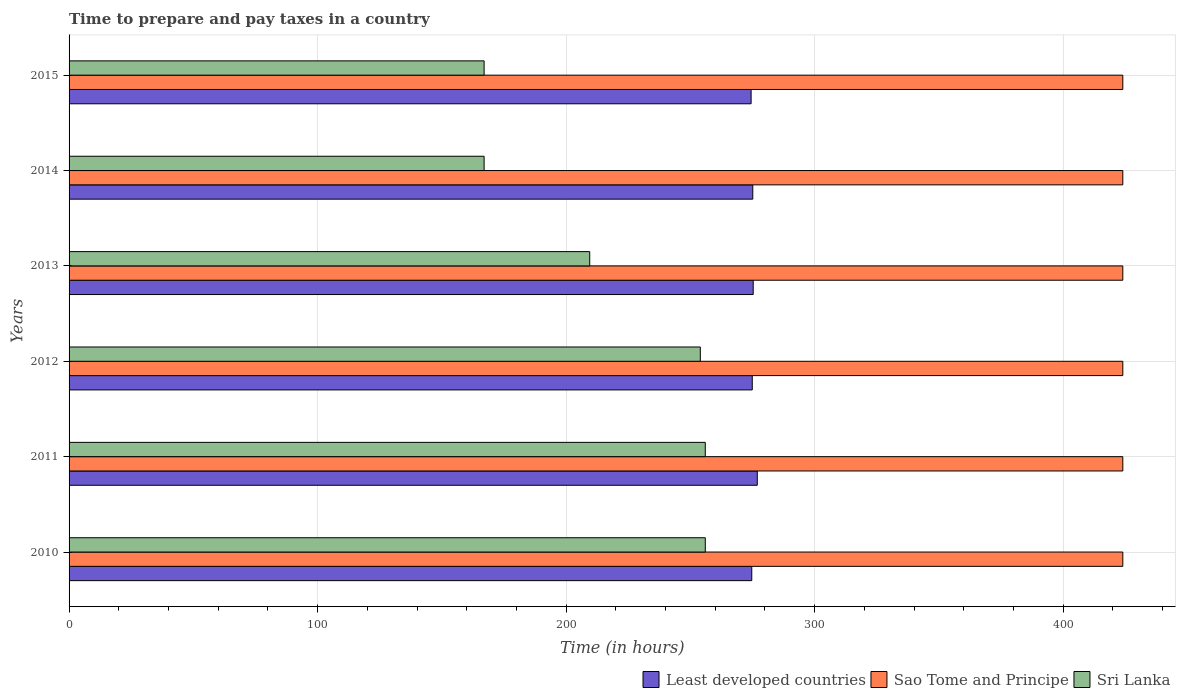How many different coloured bars are there?
Give a very brief answer. 3. Are the number of bars per tick equal to the number of legend labels?
Give a very brief answer. Yes. Are the number of bars on each tick of the Y-axis equal?
Your response must be concise. Yes. What is the number of hours required to prepare and pay taxes in Least developed countries in 2014?
Ensure brevity in your answer.  275.11. Across all years, what is the maximum number of hours required to prepare and pay taxes in Sri Lanka?
Your response must be concise. 256. Across all years, what is the minimum number of hours required to prepare and pay taxes in Sao Tome and Principe?
Offer a very short reply. 424. What is the total number of hours required to prepare and pay taxes in Sao Tome and Principe in the graph?
Your answer should be compact. 2544. What is the difference between the number of hours required to prepare and pay taxes in Least developed countries in 2012 and that in 2015?
Ensure brevity in your answer.  0.47. What is the difference between the number of hours required to prepare and pay taxes in Sri Lanka in 2014 and the number of hours required to prepare and pay taxes in Sao Tome and Principe in 2013?
Your response must be concise. -257. What is the average number of hours required to prepare and pay taxes in Sri Lanka per year?
Keep it short and to the point. 218.25. In the year 2012, what is the difference between the number of hours required to prepare and pay taxes in Sri Lanka and number of hours required to prepare and pay taxes in Least developed countries?
Give a very brief answer. -20.9. In how many years, is the number of hours required to prepare and pay taxes in Least developed countries greater than 220 hours?
Your response must be concise. 6. What is the ratio of the number of hours required to prepare and pay taxes in Least developed countries in 2011 to that in 2013?
Offer a terse response. 1.01. Is the number of hours required to prepare and pay taxes in Sao Tome and Principe in 2010 less than that in 2015?
Keep it short and to the point. No. What is the difference between the highest and the lowest number of hours required to prepare and pay taxes in Sri Lanka?
Provide a short and direct response. 89. What does the 3rd bar from the top in 2011 represents?
Keep it short and to the point. Least developed countries. What does the 2nd bar from the bottom in 2013 represents?
Offer a terse response. Sao Tome and Principe. Is it the case that in every year, the sum of the number of hours required to prepare and pay taxes in Sao Tome and Principe and number of hours required to prepare and pay taxes in Sri Lanka is greater than the number of hours required to prepare and pay taxes in Least developed countries?
Your response must be concise. Yes. How many bars are there?
Provide a succinct answer. 18. How many years are there in the graph?
Provide a short and direct response. 6. What is the difference between two consecutive major ticks on the X-axis?
Your response must be concise. 100. Where does the legend appear in the graph?
Your response must be concise. Bottom right. How many legend labels are there?
Provide a short and direct response. 3. How are the legend labels stacked?
Provide a succinct answer. Horizontal. What is the title of the graph?
Make the answer very short. Time to prepare and pay taxes in a country. Does "Brunei Darussalam" appear as one of the legend labels in the graph?
Offer a terse response. No. What is the label or title of the X-axis?
Your response must be concise. Time (in hours). What is the label or title of the Y-axis?
Offer a very short reply. Years. What is the Time (in hours) of Least developed countries in 2010?
Provide a succinct answer. 274.7. What is the Time (in hours) of Sao Tome and Principe in 2010?
Ensure brevity in your answer.  424. What is the Time (in hours) of Sri Lanka in 2010?
Provide a succinct answer. 256. What is the Time (in hours) in Least developed countries in 2011?
Offer a very short reply. 276.92. What is the Time (in hours) in Sao Tome and Principe in 2011?
Ensure brevity in your answer.  424. What is the Time (in hours) in Sri Lanka in 2011?
Your answer should be very brief. 256. What is the Time (in hours) of Least developed countries in 2012?
Give a very brief answer. 274.9. What is the Time (in hours) in Sao Tome and Principe in 2012?
Your answer should be very brief. 424. What is the Time (in hours) in Sri Lanka in 2012?
Provide a succinct answer. 254. What is the Time (in hours) in Least developed countries in 2013?
Your response must be concise. 275.28. What is the Time (in hours) of Sao Tome and Principe in 2013?
Provide a succinct answer. 424. What is the Time (in hours) of Sri Lanka in 2013?
Ensure brevity in your answer.  209.5. What is the Time (in hours) in Least developed countries in 2014?
Give a very brief answer. 275.11. What is the Time (in hours) of Sao Tome and Principe in 2014?
Make the answer very short. 424. What is the Time (in hours) of Sri Lanka in 2014?
Make the answer very short. 167. What is the Time (in hours) of Least developed countries in 2015?
Your answer should be very brief. 274.43. What is the Time (in hours) in Sao Tome and Principe in 2015?
Make the answer very short. 424. What is the Time (in hours) in Sri Lanka in 2015?
Keep it short and to the point. 167. Across all years, what is the maximum Time (in hours) in Least developed countries?
Your response must be concise. 276.92. Across all years, what is the maximum Time (in hours) in Sao Tome and Principe?
Give a very brief answer. 424. Across all years, what is the maximum Time (in hours) in Sri Lanka?
Provide a short and direct response. 256. Across all years, what is the minimum Time (in hours) of Least developed countries?
Keep it short and to the point. 274.43. Across all years, what is the minimum Time (in hours) in Sao Tome and Principe?
Keep it short and to the point. 424. Across all years, what is the minimum Time (in hours) in Sri Lanka?
Your answer should be very brief. 167. What is the total Time (in hours) in Least developed countries in the graph?
Provide a short and direct response. 1651.35. What is the total Time (in hours) of Sao Tome and Principe in the graph?
Give a very brief answer. 2544. What is the total Time (in hours) in Sri Lanka in the graph?
Keep it short and to the point. 1309.5. What is the difference between the Time (in hours) of Least developed countries in 2010 and that in 2011?
Offer a terse response. -2.21. What is the difference between the Time (in hours) in Least developed countries in 2010 and that in 2012?
Ensure brevity in your answer.  -0.2. What is the difference between the Time (in hours) of Least developed countries in 2010 and that in 2013?
Your answer should be compact. -0.58. What is the difference between the Time (in hours) in Sao Tome and Principe in 2010 and that in 2013?
Provide a short and direct response. 0. What is the difference between the Time (in hours) of Sri Lanka in 2010 and that in 2013?
Ensure brevity in your answer.  46.5. What is the difference between the Time (in hours) of Least developed countries in 2010 and that in 2014?
Make the answer very short. -0.4. What is the difference between the Time (in hours) in Sao Tome and Principe in 2010 and that in 2014?
Provide a short and direct response. 0. What is the difference between the Time (in hours) of Sri Lanka in 2010 and that in 2014?
Your response must be concise. 89. What is the difference between the Time (in hours) in Least developed countries in 2010 and that in 2015?
Offer a very short reply. 0.27. What is the difference between the Time (in hours) of Sao Tome and Principe in 2010 and that in 2015?
Your response must be concise. 0. What is the difference between the Time (in hours) of Sri Lanka in 2010 and that in 2015?
Offer a terse response. 89. What is the difference between the Time (in hours) in Least developed countries in 2011 and that in 2012?
Your answer should be very brief. 2.02. What is the difference between the Time (in hours) of Sao Tome and Principe in 2011 and that in 2012?
Provide a succinct answer. 0. What is the difference between the Time (in hours) in Least developed countries in 2011 and that in 2013?
Give a very brief answer. 1.64. What is the difference between the Time (in hours) of Sao Tome and Principe in 2011 and that in 2013?
Provide a short and direct response. 0. What is the difference between the Time (in hours) in Sri Lanka in 2011 and that in 2013?
Offer a very short reply. 46.5. What is the difference between the Time (in hours) in Least developed countries in 2011 and that in 2014?
Provide a short and direct response. 1.81. What is the difference between the Time (in hours) in Sri Lanka in 2011 and that in 2014?
Offer a very short reply. 89. What is the difference between the Time (in hours) in Least developed countries in 2011 and that in 2015?
Keep it short and to the point. 2.48. What is the difference between the Time (in hours) of Sri Lanka in 2011 and that in 2015?
Give a very brief answer. 89. What is the difference between the Time (in hours) of Least developed countries in 2012 and that in 2013?
Keep it short and to the point. -0.38. What is the difference between the Time (in hours) in Sri Lanka in 2012 and that in 2013?
Provide a succinct answer. 44.5. What is the difference between the Time (in hours) of Least developed countries in 2012 and that in 2014?
Your response must be concise. -0.21. What is the difference between the Time (in hours) in Sao Tome and Principe in 2012 and that in 2014?
Make the answer very short. 0. What is the difference between the Time (in hours) in Sri Lanka in 2012 and that in 2014?
Offer a terse response. 87. What is the difference between the Time (in hours) of Least developed countries in 2012 and that in 2015?
Your answer should be very brief. 0.47. What is the difference between the Time (in hours) in Sri Lanka in 2012 and that in 2015?
Your response must be concise. 87. What is the difference between the Time (in hours) in Least developed countries in 2013 and that in 2014?
Ensure brevity in your answer.  0.17. What is the difference between the Time (in hours) of Sao Tome and Principe in 2013 and that in 2014?
Make the answer very short. 0. What is the difference between the Time (in hours) in Sri Lanka in 2013 and that in 2014?
Your response must be concise. 42.5. What is the difference between the Time (in hours) of Least developed countries in 2013 and that in 2015?
Provide a succinct answer. 0.85. What is the difference between the Time (in hours) of Sao Tome and Principe in 2013 and that in 2015?
Offer a terse response. 0. What is the difference between the Time (in hours) of Sri Lanka in 2013 and that in 2015?
Your response must be concise. 42.5. What is the difference between the Time (in hours) of Least developed countries in 2014 and that in 2015?
Offer a very short reply. 0.67. What is the difference between the Time (in hours) in Least developed countries in 2010 and the Time (in hours) in Sao Tome and Principe in 2011?
Your answer should be very brief. -149.3. What is the difference between the Time (in hours) of Least developed countries in 2010 and the Time (in hours) of Sri Lanka in 2011?
Your answer should be very brief. 18.7. What is the difference between the Time (in hours) of Sao Tome and Principe in 2010 and the Time (in hours) of Sri Lanka in 2011?
Your answer should be compact. 168. What is the difference between the Time (in hours) in Least developed countries in 2010 and the Time (in hours) in Sao Tome and Principe in 2012?
Make the answer very short. -149.3. What is the difference between the Time (in hours) of Least developed countries in 2010 and the Time (in hours) of Sri Lanka in 2012?
Your response must be concise. 20.7. What is the difference between the Time (in hours) of Sao Tome and Principe in 2010 and the Time (in hours) of Sri Lanka in 2012?
Keep it short and to the point. 170. What is the difference between the Time (in hours) of Least developed countries in 2010 and the Time (in hours) of Sao Tome and Principe in 2013?
Give a very brief answer. -149.3. What is the difference between the Time (in hours) of Least developed countries in 2010 and the Time (in hours) of Sri Lanka in 2013?
Offer a terse response. 65.2. What is the difference between the Time (in hours) of Sao Tome and Principe in 2010 and the Time (in hours) of Sri Lanka in 2013?
Make the answer very short. 214.5. What is the difference between the Time (in hours) in Least developed countries in 2010 and the Time (in hours) in Sao Tome and Principe in 2014?
Offer a terse response. -149.3. What is the difference between the Time (in hours) of Least developed countries in 2010 and the Time (in hours) of Sri Lanka in 2014?
Give a very brief answer. 107.7. What is the difference between the Time (in hours) in Sao Tome and Principe in 2010 and the Time (in hours) in Sri Lanka in 2014?
Ensure brevity in your answer.  257. What is the difference between the Time (in hours) in Least developed countries in 2010 and the Time (in hours) in Sao Tome and Principe in 2015?
Your answer should be very brief. -149.3. What is the difference between the Time (in hours) of Least developed countries in 2010 and the Time (in hours) of Sri Lanka in 2015?
Give a very brief answer. 107.7. What is the difference between the Time (in hours) of Sao Tome and Principe in 2010 and the Time (in hours) of Sri Lanka in 2015?
Give a very brief answer. 257. What is the difference between the Time (in hours) of Least developed countries in 2011 and the Time (in hours) of Sao Tome and Principe in 2012?
Ensure brevity in your answer.  -147.08. What is the difference between the Time (in hours) of Least developed countries in 2011 and the Time (in hours) of Sri Lanka in 2012?
Offer a terse response. 22.92. What is the difference between the Time (in hours) of Sao Tome and Principe in 2011 and the Time (in hours) of Sri Lanka in 2012?
Provide a succinct answer. 170. What is the difference between the Time (in hours) in Least developed countries in 2011 and the Time (in hours) in Sao Tome and Principe in 2013?
Offer a terse response. -147.08. What is the difference between the Time (in hours) in Least developed countries in 2011 and the Time (in hours) in Sri Lanka in 2013?
Offer a very short reply. 67.42. What is the difference between the Time (in hours) of Sao Tome and Principe in 2011 and the Time (in hours) of Sri Lanka in 2013?
Offer a very short reply. 214.5. What is the difference between the Time (in hours) of Least developed countries in 2011 and the Time (in hours) of Sao Tome and Principe in 2014?
Keep it short and to the point. -147.08. What is the difference between the Time (in hours) of Least developed countries in 2011 and the Time (in hours) of Sri Lanka in 2014?
Your answer should be compact. 109.92. What is the difference between the Time (in hours) in Sao Tome and Principe in 2011 and the Time (in hours) in Sri Lanka in 2014?
Make the answer very short. 257. What is the difference between the Time (in hours) in Least developed countries in 2011 and the Time (in hours) in Sao Tome and Principe in 2015?
Your response must be concise. -147.08. What is the difference between the Time (in hours) of Least developed countries in 2011 and the Time (in hours) of Sri Lanka in 2015?
Your answer should be very brief. 109.92. What is the difference between the Time (in hours) of Sao Tome and Principe in 2011 and the Time (in hours) of Sri Lanka in 2015?
Ensure brevity in your answer.  257. What is the difference between the Time (in hours) of Least developed countries in 2012 and the Time (in hours) of Sao Tome and Principe in 2013?
Offer a terse response. -149.1. What is the difference between the Time (in hours) in Least developed countries in 2012 and the Time (in hours) in Sri Lanka in 2013?
Keep it short and to the point. 65.4. What is the difference between the Time (in hours) in Sao Tome and Principe in 2012 and the Time (in hours) in Sri Lanka in 2013?
Your answer should be very brief. 214.5. What is the difference between the Time (in hours) in Least developed countries in 2012 and the Time (in hours) in Sao Tome and Principe in 2014?
Offer a very short reply. -149.1. What is the difference between the Time (in hours) in Least developed countries in 2012 and the Time (in hours) in Sri Lanka in 2014?
Ensure brevity in your answer.  107.9. What is the difference between the Time (in hours) in Sao Tome and Principe in 2012 and the Time (in hours) in Sri Lanka in 2014?
Your answer should be compact. 257. What is the difference between the Time (in hours) in Least developed countries in 2012 and the Time (in hours) in Sao Tome and Principe in 2015?
Give a very brief answer. -149.1. What is the difference between the Time (in hours) of Least developed countries in 2012 and the Time (in hours) of Sri Lanka in 2015?
Ensure brevity in your answer.  107.9. What is the difference between the Time (in hours) in Sao Tome and Principe in 2012 and the Time (in hours) in Sri Lanka in 2015?
Provide a succinct answer. 257. What is the difference between the Time (in hours) in Least developed countries in 2013 and the Time (in hours) in Sao Tome and Principe in 2014?
Make the answer very short. -148.72. What is the difference between the Time (in hours) of Least developed countries in 2013 and the Time (in hours) of Sri Lanka in 2014?
Give a very brief answer. 108.28. What is the difference between the Time (in hours) of Sao Tome and Principe in 2013 and the Time (in hours) of Sri Lanka in 2014?
Provide a succinct answer. 257. What is the difference between the Time (in hours) in Least developed countries in 2013 and the Time (in hours) in Sao Tome and Principe in 2015?
Provide a succinct answer. -148.72. What is the difference between the Time (in hours) of Least developed countries in 2013 and the Time (in hours) of Sri Lanka in 2015?
Keep it short and to the point. 108.28. What is the difference between the Time (in hours) in Sao Tome and Principe in 2013 and the Time (in hours) in Sri Lanka in 2015?
Provide a succinct answer. 257. What is the difference between the Time (in hours) in Least developed countries in 2014 and the Time (in hours) in Sao Tome and Principe in 2015?
Give a very brief answer. -148.89. What is the difference between the Time (in hours) of Least developed countries in 2014 and the Time (in hours) of Sri Lanka in 2015?
Keep it short and to the point. 108.11. What is the difference between the Time (in hours) in Sao Tome and Principe in 2014 and the Time (in hours) in Sri Lanka in 2015?
Give a very brief answer. 257. What is the average Time (in hours) of Least developed countries per year?
Offer a very short reply. 275.22. What is the average Time (in hours) of Sao Tome and Principe per year?
Offer a very short reply. 424. What is the average Time (in hours) of Sri Lanka per year?
Provide a succinct answer. 218.25. In the year 2010, what is the difference between the Time (in hours) of Least developed countries and Time (in hours) of Sao Tome and Principe?
Provide a short and direct response. -149.3. In the year 2010, what is the difference between the Time (in hours) in Least developed countries and Time (in hours) in Sri Lanka?
Give a very brief answer. 18.7. In the year 2010, what is the difference between the Time (in hours) of Sao Tome and Principe and Time (in hours) of Sri Lanka?
Give a very brief answer. 168. In the year 2011, what is the difference between the Time (in hours) of Least developed countries and Time (in hours) of Sao Tome and Principe?
Offer a very short reply. -147.08. In the year 2011, what is the difference between the Time (in hours) of Least developed countries and Time (in hours) of Sri Lanka?
Give a very brief answer. 20.92. In the year 2011, what is the difference between the Time (in hours) of Sao Tome and Principe and Time (in hours) of Sri Lanka?
Provide a short and direct response. 168. In the year 2012, what is the difference between the Time (in hours) of Least developed countries and Time (in hours) of Sao Tome and Principe?
Your response must be concise. -149.1. In the year 2012, what is the difference between the Time (in hours) in Least developed countries and Time (in hours) in Sri Lanka?
Your response must be concise. 20.9. In the year 2012, what is the difference between the Time (in hours) in Sao Tome and Principe and Time (in hours) in Sri Lanka?
Keep it short and to the point. 170. In the year 2013, what is the difference between the Time (in hours) in Least developed countries and Time (in hours) in Sao Tome and Principe?
Your answer should be compact. -148.72. In the year 2013, what is the difference between the Time (in hours) of Least developed countries and Time (in hours) of Sri Lanka?
Ensure brevity in your answer.  65.78. In the year 2013, what is the difference between the Time (in hours) in Sao Tome and Principe and Time (in hours) in Sri Lanka?
Your answer should be compact. 214.5. In the year 2014, what is the difference between the Time (in hours) in Least developed countries and Time (in hours) in Sao Tome and Principe?
Your answer should be compact. -148.89. In the year 2014, what is the difference between the Time (in hours) in Least developed countries and Time (in hours) in Sri Lanka?
Provide a succinct answer. 108.11. In the year 2014, what is the difference between the Time (in hours) in Sao Tome and Principe and Time (in hours) in Sri Lanka?
Your response must be concise. 257. In the year 2015, what is the difference between the Time (in hours) of Least developed countries and Time (in hours) of Sao Tome and Principe?
Make the answer very short. -149.57. In the year 2015, what is the difference between the Time (in hours) in Least developed countries and Time (in hours) in Sri Lanka?
Your response must be concise. 107.43. In the year 2015, what is the difference between the Time (in hours) of Sao Tome and Principe and Time (in hours) of Sri Lanka?
Make the answer very short. 257. What is the ratio of the Time (in hours) in Least developed countries in 2010 to that in 2011?
Your answer should be compact. 0.99. What is the ratio of the Time (in hours) of Sri Lanka in 2010 to that in 2011?
Your response must be concise. 1. What is the ratio of the Time (in hours) in Least developed countries in 2010 to that in 2012?
Provide a short and direct response. 1. What is the ratio of the Time (in hours) of Sri Lanka in 2010 to that in 2012?
Offer a very short reply. 1.01. What is the ratio of the Time (in hours) of Sri Lanka in 2010 to that in 2013?
Your response must be concise. 1.22. What is the ratio of the Time (in hours) of Sri Lanka in 2010 to that in 2014?
Make the answer very short. 1.53. What is the ratio of the Time (in hours) of Least developed countries in 2010 to that in 2015?
Keep it short and to the point. 1. What is the ratio of the Time (in hours) in Sao Tome and Principe in 2010 to that in 2015?
Make the answer very short. 1. What is the ratio of the Time (in hours) of Sri Lanka in 2010 to that in 2015?
Provide a short and direct response. 1.53. What is the ratio of the Time (in hours) in Least developed countries in 2011 to that in 2012?
Offer a very short reply. 1.01. What is the ratio of the Time (in hours) of Sao Tome and Principe in 2011 to that in 2012?
Give a very brief answer. 1. What is the ratio of the Time (in hours) of Sri Lanka in 2011 to that in 2012?
Offer a terse response. 1.01. What is the ratio of the Time (in hours) in Least developed countries in 2011 to that in 2013?
Offer a terse response. 1.01. What is the ratio of the Time (in hours) in Sri Lanka in 2011 to that in 2013?
Keep it short and to the point. 1.22. What is the ratio of the Time (in hours) of Least developed countries in 2011 to that in 2014?
Give a very brief answer. 1.01. What is the ratio of the Time (in hours) of Sri Lanka in 2011 to that in 2014?
Make the answer very short. 1.53. What is the ratio of the Time (in hours) of Least developed countries in 2011 to that in 2015?
Provide a short and direct response. 1.01. What is the ratio of the Time (in hours) of Sri Lanka in 2011 to that in 2015?
Keep it short and to the point. 1.53. What is the ratio of the Time (in hours) in Sao Tome and Principe in 2012 to that in 2013?
Make the answer very short. 1. What is the ratio of the Time (in hours) in Sri Lanka in 2012 to that in 2013?
Your response must be concise. 1.21. What is the ratio of the Time (in hours) in Least developed countries in 2012 to that in 2014?
Give a very brief answer. 1. What is the ratio of the Time (in hours) in Sao Tome and Principe in 2012 to that in 2014?
Offer a terse response. 1. What is the ratio of the Time (in hours) of Sri Lanka in 2012 to that in 2014?
Keep it short and to the point. 1.52. What is the ratio of the Time (in hours) in Sri Lanka in 2012 to that in 2015?
Your response must be concise. 1.52. What is the ratio of the Time (in hours) of Sri Lanka in 2013 to that in 2014?
Provide a succinct answer. 1.25. What is the ratio of the Time (in hours) of Sao Tome and Principe in 2013 to that in 2015?
Your answer should be compact. 1. What is the ratio of the Time (in hours) in Sri Lanka in 2013 to that in 2015?
Ensure brevity in your answer.  1.25. What is the difference between the highest and the second highest Time (in hours) in Least developed countries?
Your answer should be very brief. 1.64. What is the difference between the highest and the second highest Time (in hours) in Sri Lanka?
Ensure brevity in your answer.  0. What is the difference between the highest and the lowest Time (in hours) in Least developed countries?
Give a very brief answer. 2.48. What is the difference between the highest and the lowest Time (in hours) in Sri Lanka?
Your response must be concise. 89. 